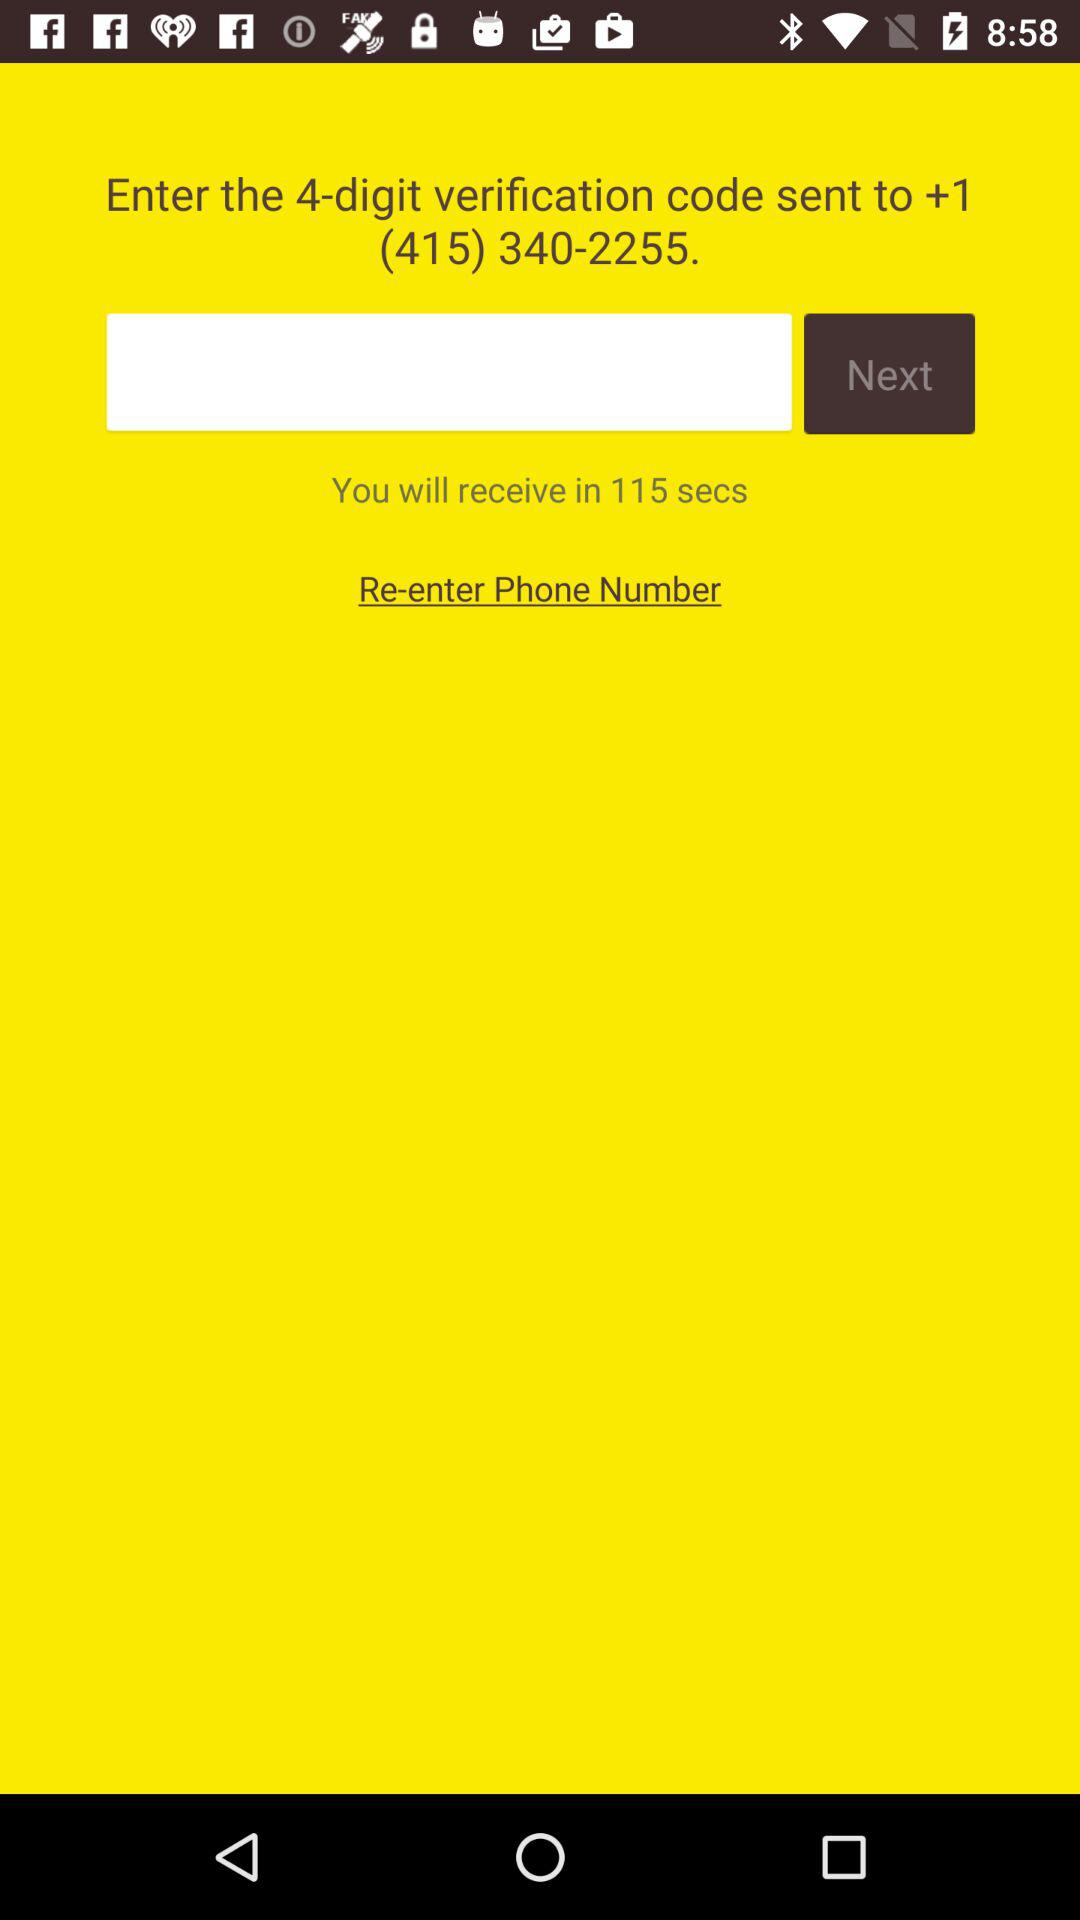How many more seconds until I receive the verification code?
Answer the question using a single word or phrase. 115 